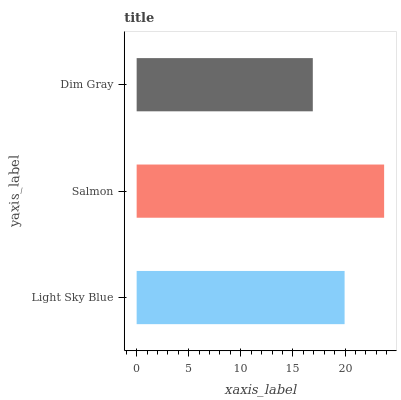Is Dim Gray the minimum?
Answer yes or no. Yes. Is Salmon the maximum?
Answer yes or no. Yes. Is Salmon the minimum?
Answer yes or no. No. Is Dim Gray the maximum?
Answer yes or no. No. Is Salmon greater than Dim Gray?
Answer yes or no. Yes. Is Dim Gray less than Salmon?
Answer yes or no. Yes. Is Dim Gray greater than Salmon?
Answer yes or no. No. Is Salmon less than Dim Gray?
Answer yes or no. No. Is Light Sky Blue the high median?
Answer yes or no. Yes. Is Light Sky Blue the low median?
Answer yes or no. Yes. Is Salmon the high median?
Answer yes or no. No. Is Dim Gray the low median?
Answer yes or no. No. 